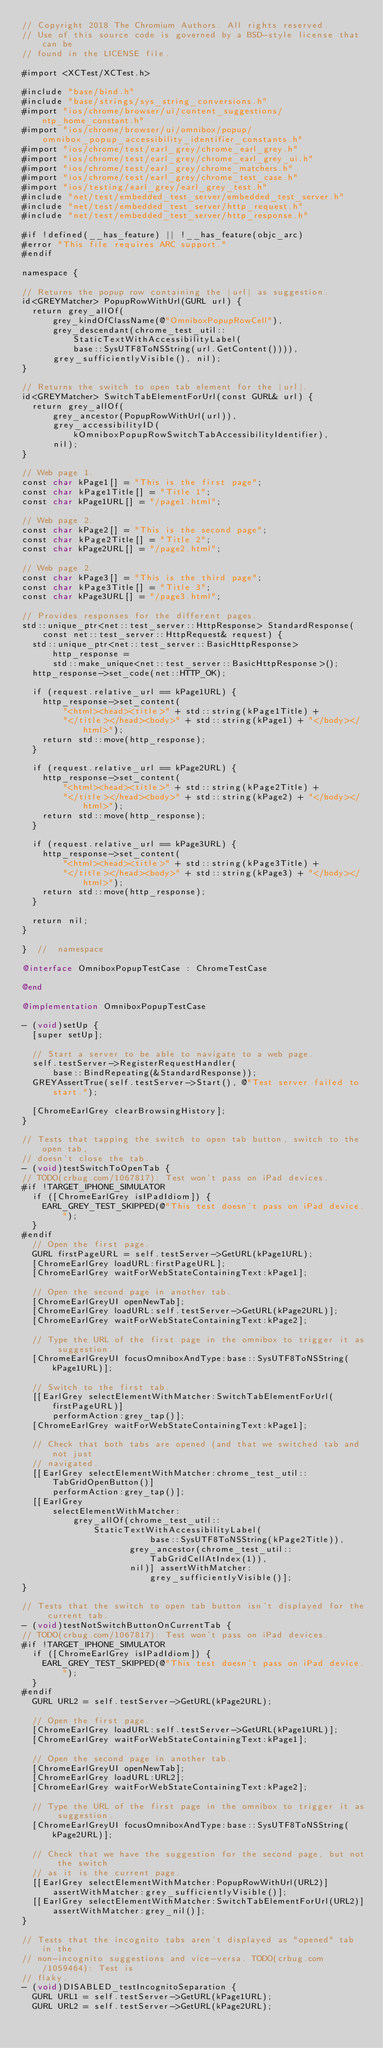Convert code to text. <code><loc_0><loc_0><loc_500><loc_500><_ObjectiveC_>// Copyright 2018 The Chromium Authors. All rights reserved.
// Use of this source code is governed by a BSD-style license that can be
// found in the LICENSE file.

#import <XCTest/XCTest.h>

#include "base/bind.h"
#include "base/strings/sys_string_conversions.h"
#import "ios/chrome/browser/ui/content_suggestions/ntp_home_constant.h"
#import "ios/chrome/browser/ui/omnibox/popup/omnibox_popup_accessibility_identifier_constants.h"
#import "ios/chrome/test/earl_grey/chrome_earl_grey.h"
#import "ios/chrome/test/earl_grey/chrome_earl_grey_ui.h"
#import "ios/chrome/test/earl_grey/chrome_matchers.h"
#import "ios/chrome/test/earl_grey/chrome_test_case.h"
#import "ios/testing/earl_grey/earl_grey_test.h"
#include "net/test/embedded_test_server/embedded_test_server.h"
#include "net/test/embedded_test_server/http_request.h"
#include "net/test/embedded_test_server/http_response.h"

#if !defined(__has_feature) || !__has_feature(objc_arc)
#error "This file requires ARC support."
#endif

namespace {

// Returns the popup row containing the |url| as suggestion.
id<GREYMatcher> PopupRowWithUrl(GURL url) {
  return grey_allOf(
      grey_kindOfClassName(@"OmniboxPopupRowCell"),
      grey_descendant(chrome_test_util::StaticTextWithAccessibilityLabel(
          base::SysUTF8ToNSString(url.GetContent()))),
      grey_sufficientlyVisible(), nil);
}

// Returns the switch to open tab element for the |url|.
id<GREYMatcher> SwitchTabElementForUrl(const GURL& url) {
  return grey_allOf(
      grey_ancestor(PopupRowWithUrl(url)),
      grey_accessibilityID(kOmniboxPopupRowSwitchTabAccessibilityIdentifier),
      nil);
}

// Web page 1.
const char kPage1[] = "This is the first page";
const char kPage1Title[] = "Title 1";
const char kPage1URL[] = "/page1.html";

// Web page 2.
const char kPage2[] = "This is the second page";
const char kPage2Title[] = "Title 2";
const char kPage2URL[] = "/page2.html";

// Web page 2.
const char kPage3[] = "This is the third page";
const char kPage3Title[] = "Title 3";
const char kPage3URL[] = "/page3.html";

// Provides responses for the different pages.
std::unique_ptr<net::test_server::HttpResponse> StandardResponse(
    const net::test_server::HttpRequest& request) {
  std::unique_ptr<net::test_server::BasicHttpResponse> http_response =
      std::make_unique<net::test_server::BasicHttpResponse>();
  http_response->set_code(net::HTTP_OK);

  if (request.relative_url == kPage1URL) {
    http_response->set_content(
        "<html><head><title>" + std::string(kPage1Title) +
        "</title></head><body>" + std::string(kPage1) + "</body></html>");
    return std::move(http_response);
  }

  if (request.relative_url == kPage2URL) {
    http_response->set_content(
        "<html><head><title>" + std::string(kPage2Title) +
        "</title></head><body>" + std::string(kPage2) + "</body></html>");
    return std::move(http_response);
  }

  if (request.relative_url == kPage3URL) {
    http_response->set_content(
        "<html><head><title>" + std::string(kPage3Title) +
        "</title></head><body>" + std::string(kPage3) + "</body></html>");
    return std::move(http_response);
  }

  return nil;
}

}  //  namespace

@interface OmniboxPopupTestCase : ChromeTestCase

@end

@implementation OmniboxPopupTestCase

- (void)setUp {
  [super setUp];

  // Start a server to be able to navigate to a web page.
  self.testServer->RegisterRequestHandler(
      base::BindRepeating(&StandardResponse));
  GREYAssertTrue(self.testServer->Start(), @"Test server failed to start.");

  [ChromeEarlGrey clearBrowsingHistory];
}

// Tests that tapping the switch to open tab button, switch to the open tab,
// doesn't close the tab.
- (void)testSwitchToOpenTab {
// TODO(crbug.com/1067817): Test won't pass on iPad devices.
#if !TARGET_IPHONE_SIMULATOR
  if ([ChromeEarlGrey isIPadIdiom]) {
    EARL_GREY_TEST_SKIPPED(@"This test doesn't pass on iPad device.");
  }
#endif
  // Open the first page.
  GURL firstPageURL = self.testServer->GetURL(kPage1URL);
  [ChromeEarlGrey loadURL:firstPageURL];
  [ChromeEarlGrey waitForWebStateContainingText:kPage1];

  // Open the second page in another tab.
  [ChromeEarlGreyUI openNewTab];
  [ChromeEarlGrey loadURL:self.testServer->GetURL(kPage2URL)];
  [ChromeEarlGrey waitForWebStateContainingText:kPage2];

  // Type the URL of the first page in the omnibox to trigger it as suggestion.
  [ChromeEarlGreyUI focusOmniboxAndType:base::SysUTF8ToNSString(kPage1URL)];

  // Switch to the first tab.
  [[EarlGrey selectElementWithMatcher:SwitchTabElementForUrl(firstPageURL)]
      performAction:grey_tap()];
  [ChromeEarlGrey waitForWebStateContainingText:kPage1];

  // Check that both tabs are opened (and that we switched tab and not just
  // navigated.
  [[EarlGrey selectElementWithMatcher:chrome_test_util::TabGridOpenButton()]
      performAction:grey_tap()];
  [[EarlGrey
      selectElementWithMatcher:
          grey_allOf(chrome_test_util::StaticTextWithAccessibilityLabel(
                         base::SysUTF8ToNSString(kPage2Title)),
                     grey_ancestor(chrome_test_util::TabGridCellAtIndex(1)),
                     nil)] assertWithMatcher:grey_sufficientlyVisible()];
}

// Tests that the switch to open tab button isn't displayed for the current tab.
- (void)testNotSwitchButtonOnCurrentTab {
// TODO(crbug.com/1067817): Test won't pass on iPad devices.
#if !TARGET_IPHONE_SIMULATOR
  if ([ChromeEarlGrey isIPadIdiom]) {
    EARL_GREY_TEST_SKIPPED(@"This test doesn't pass on iPad device.");
  }
#endif
  GURL URL2 = self.testServer->GetURL(kPage2URL);

  // Open the first page.
  [ChromeEarlGrey loadURL:self.testServer->GetURL(kPage1URL)];
  [ChromeEarlGrey waitForWebStateContainingText:kPage1];

  // Open the second page in another tab.
  [ChromeEarlGreyUI openNewTab];
  [ChromeEarlGrey loadURL:URL2];
  [ChromeEarlGrey waitForWebStateContainingText:kPage2];

  // Type the URL of the first page in the omnibox to trigger it as suggestion.
  [ChromeEarlGreyUI focusOmniboxAndType:base::SysUTF8ToNSString(kPage2URL)];

  // Check that we have the suggestion for the second page, but not the switch
  // as it is the current page.
  [[EarlGrey selectElementWithMatcher:PopupRowWithUrl(URL2)]
      assertWithMatcher:grey_sufficientlyVisible()];
  [[EarlGrey selectElementWithMatcher:SwitchTabElementForUrl(URL2)]
      assertWithMatcher:grey_nil()];
}

// Tests that the incognito tabs aren't displayed as "opened" tab in the
// non-incognito suggestions and vice-versa. TODO(crbug.com/1059464): Test is
// flaky.
- (void)DISABLED_testIncognitoSeparation {
  GURL URL1 = self.testServer->GetURL(kPage1URL);
  GURL URL2 = self.testServer->GetURL(kPage2URL);</code> 